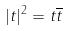Convert formula to latex. <formula><loc_0><loc_0><loc_500><loc_500>| t | ^ { 2 } = t \overline { t }</formula> 